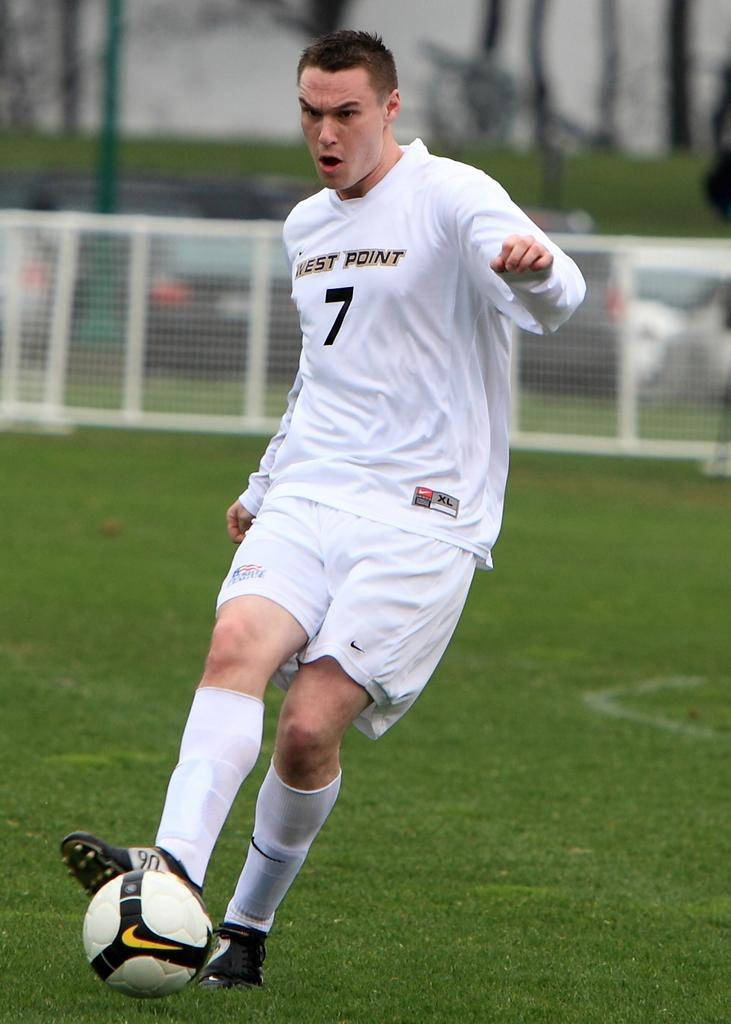What is the main subject of the image? There is a sports man in the center of the image. What is the sports man doing in the image? The sports man is hitting a ball with his leg. What can be seen in the background of the image? There is a fence and a car in the background of the image. What is the price of the expert's advice on the coast in the image? There is no expert, coast, or price mentioned in the image. The image features a sports man hitting a ball with his leg, and there is a fence and a car in the background. 